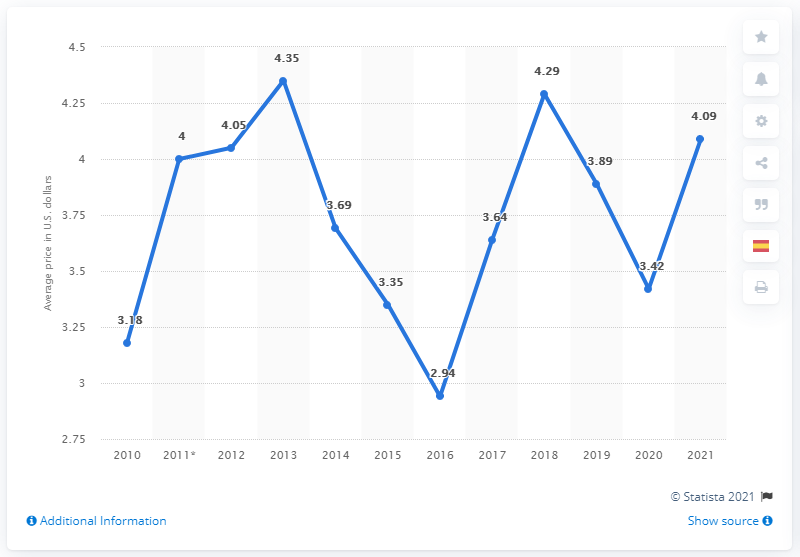Point out several critical features in this image. In 2021, Chile was one of the Latin American countries with the highest prices for a Big Mac. 